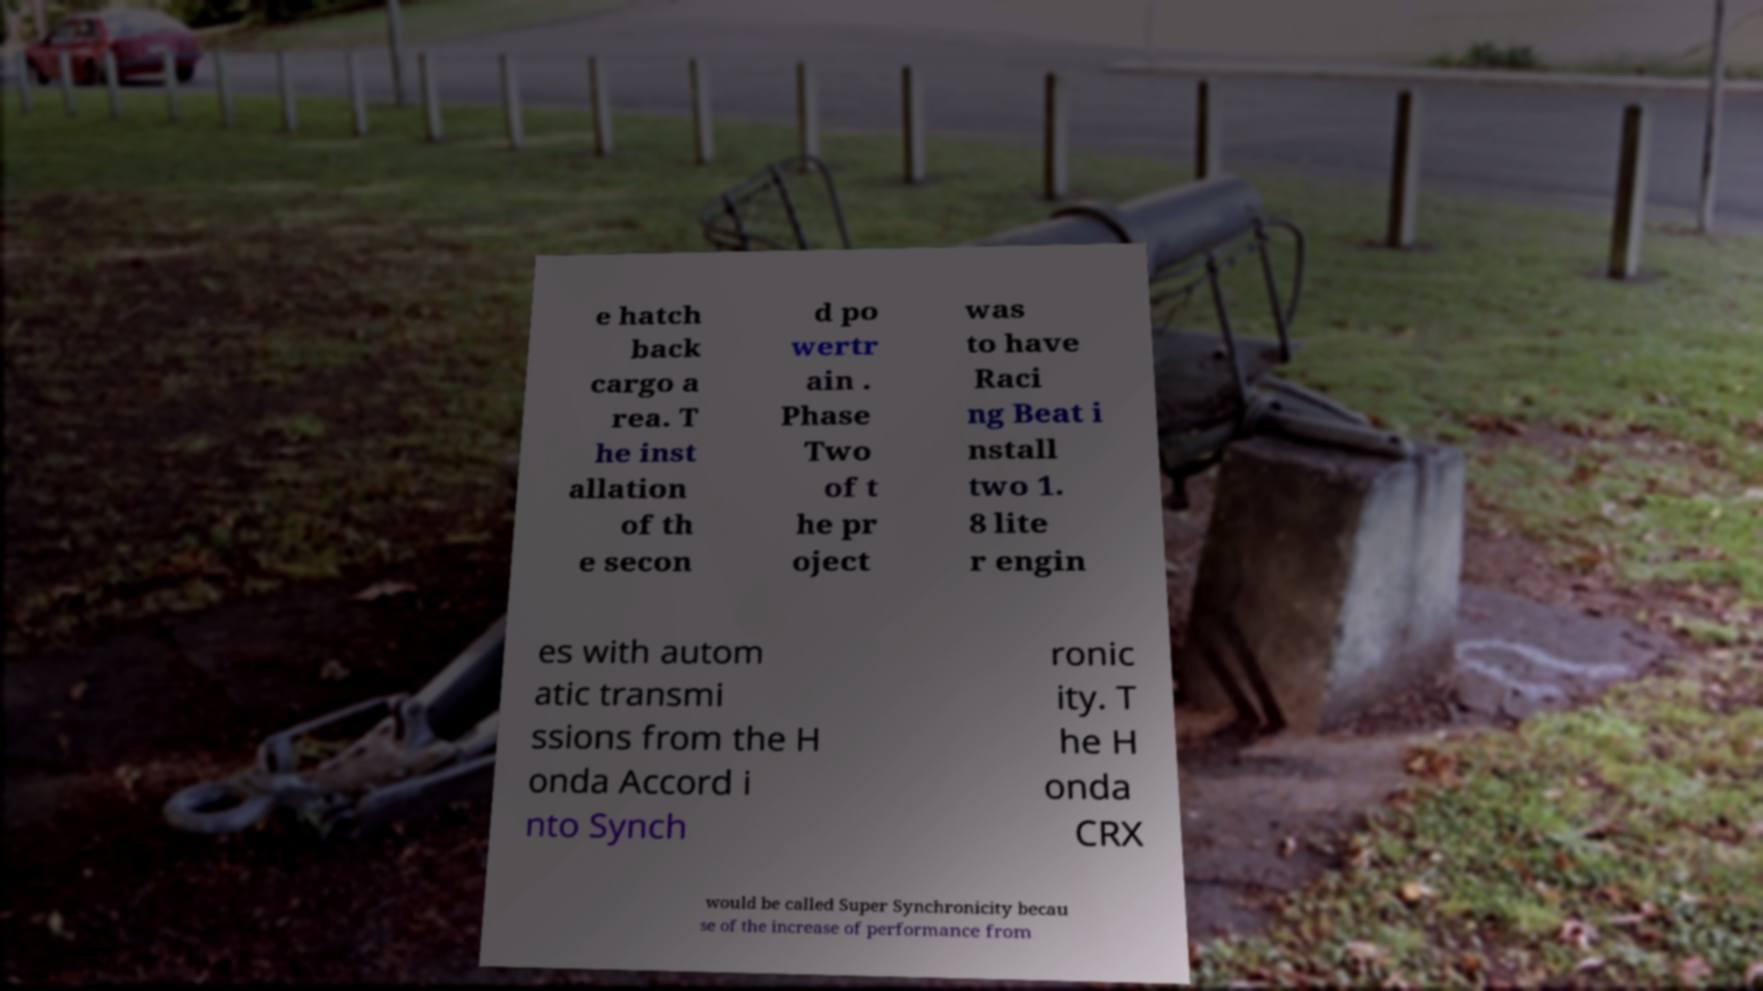For documentation purposes, I need the text within this image transcribed. Could you provide that? e hatch back cargo a rea. T he inst allation of th e secon d po wertr ain . Phase Two of t he pr oject was to have Raci ng Beat i nstall two 1. 8 lite r engin es with autom atic transmi ssions from the H onda Accord i nto Synch ronic ity. T he H onda CRX would be called Super Synchronicity becau se of the increase of performance from 